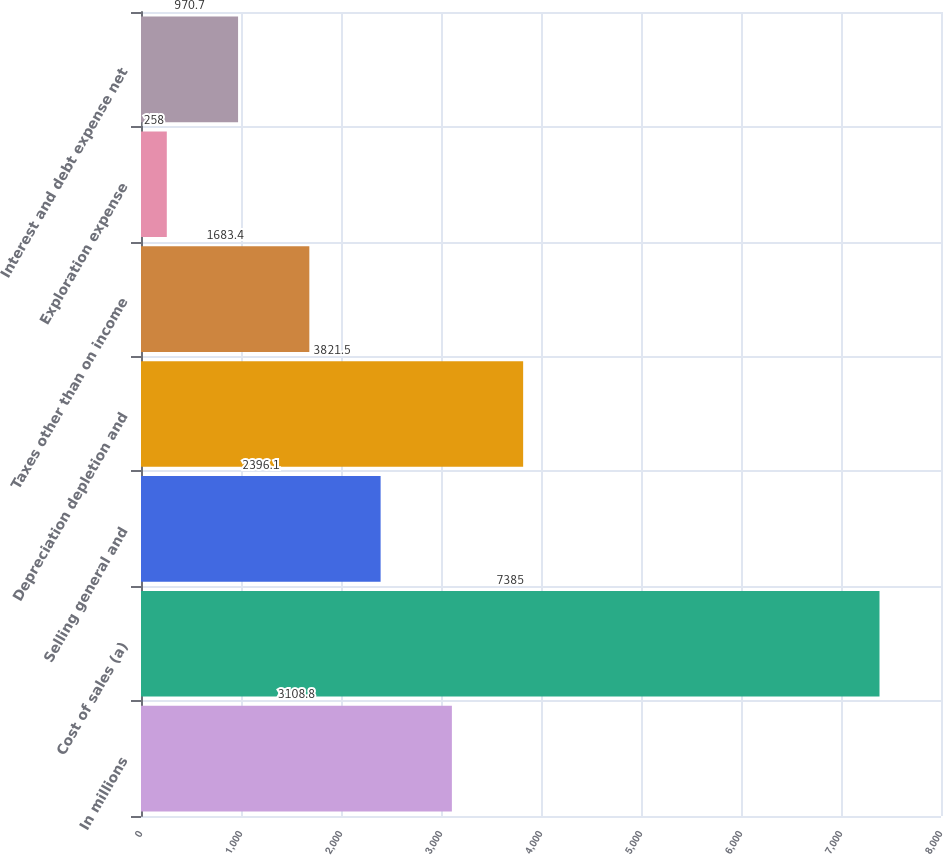Convert chart. <chart><loc_0><loc_0><loc_500><loc_500><bar_chart><fcel>In millions<fcel>Cost of sales (a)<fcel>Selling general and<fcel>Depreciation depletion and<fcel>Taxes other than on income<fcel>Exploration expense<fcel>Interest and debt expense net<nl><fcel>3108.8<fcel>7385<fcel>2396.1<fcel>3821.5<fcel>1683.4<fcel>258<fcel>970.7<nl></chart> 